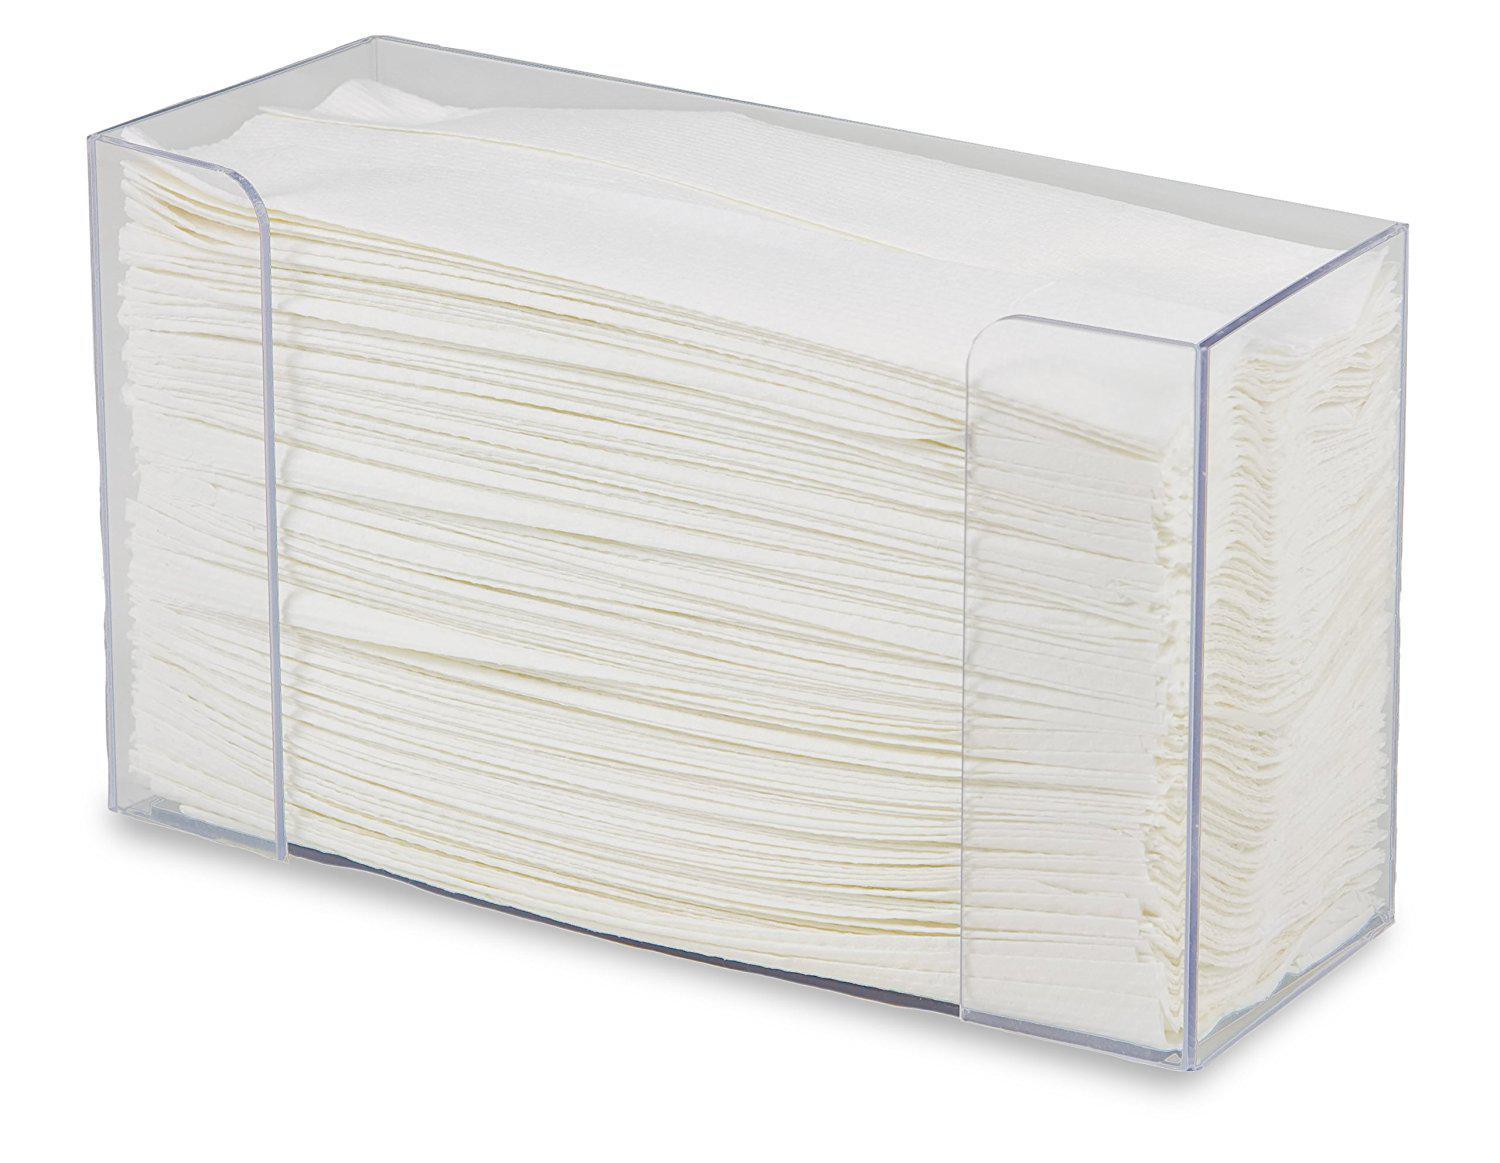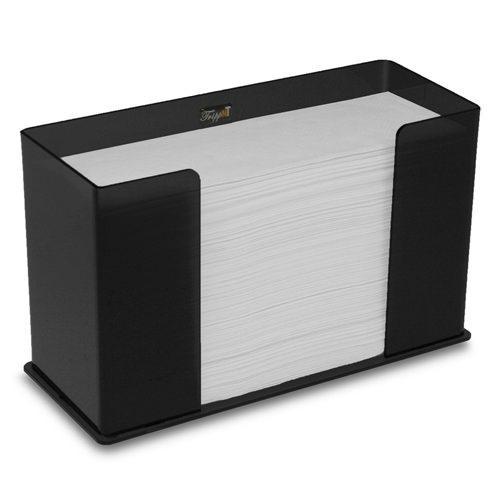The first image is the image on the left, the second image is the image on the right. For the images displayed, is the sentence "In at least one image there is a clear plastic paper towel holder with the white paper towel coming out the bottom." factually correct? Answer yes or no. No. The first image is the image on the left, the second image is the image on the right. Analyze the images presented: Is the assertion "A clear paper towel holder is full and has one towel hanging out the bottom." valid? Answer yes or no. No. 